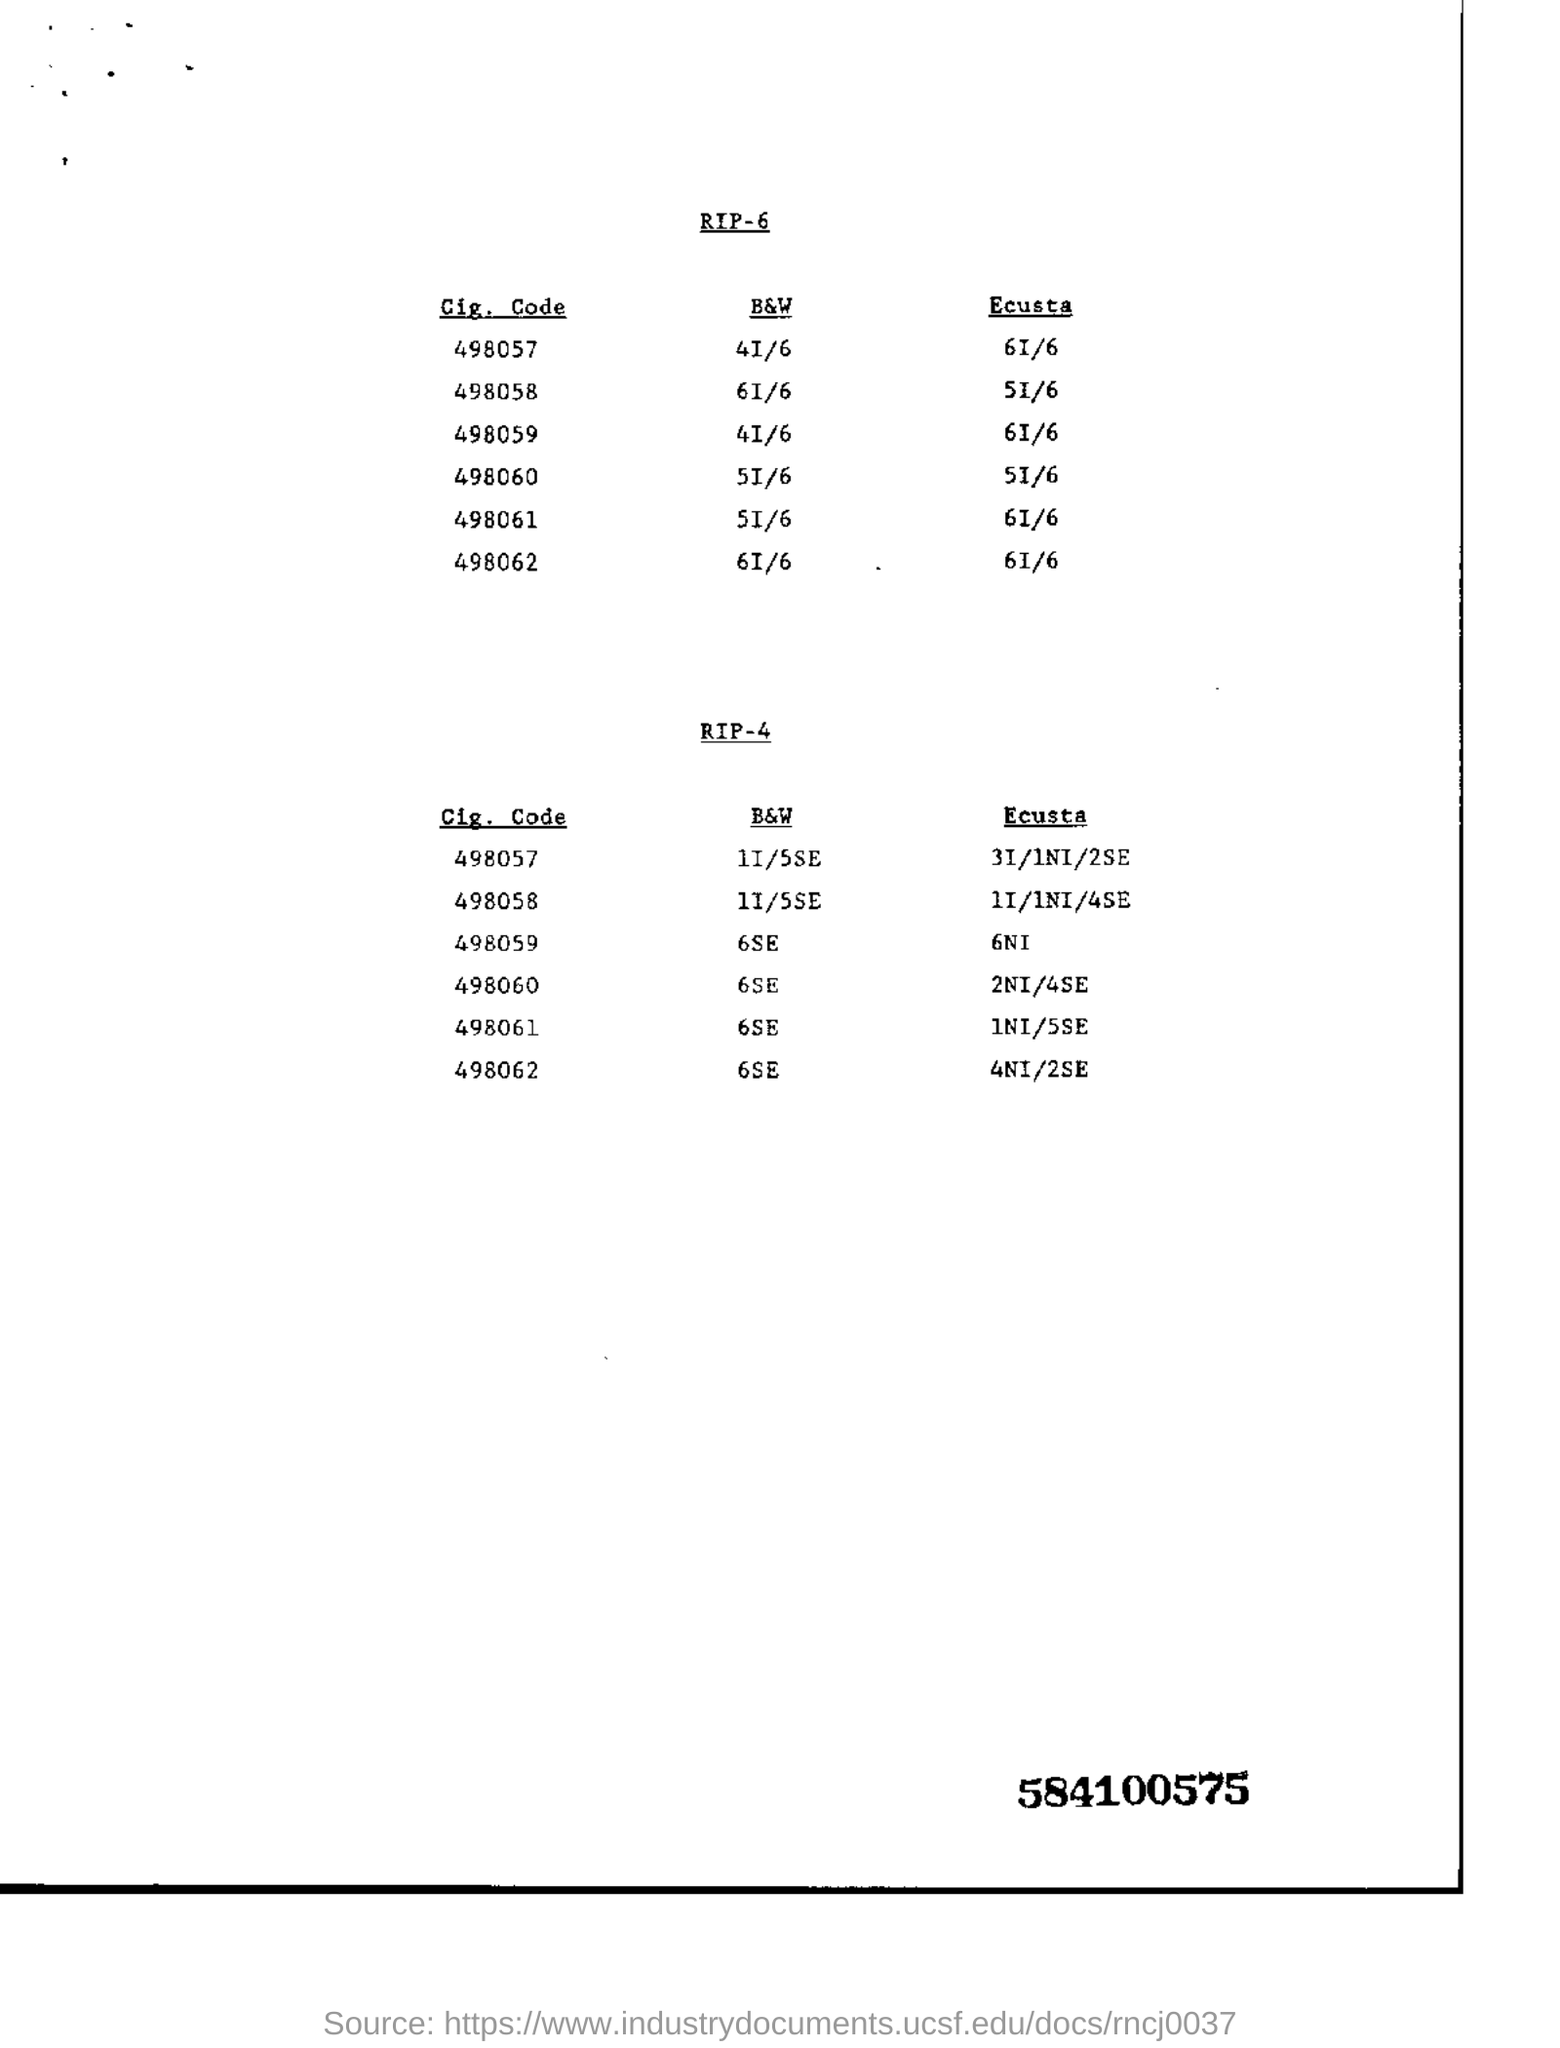Point out several critical features in this image. The nine-digit number mentioned in bold is 5841005759. The Ecusta of Cig. Code 498062 is mentioned in RIP-6, and it is 6I/6.. Cigarette Code 498062 and Black & White 6SE is mentioned in RIP-4 documentation. 